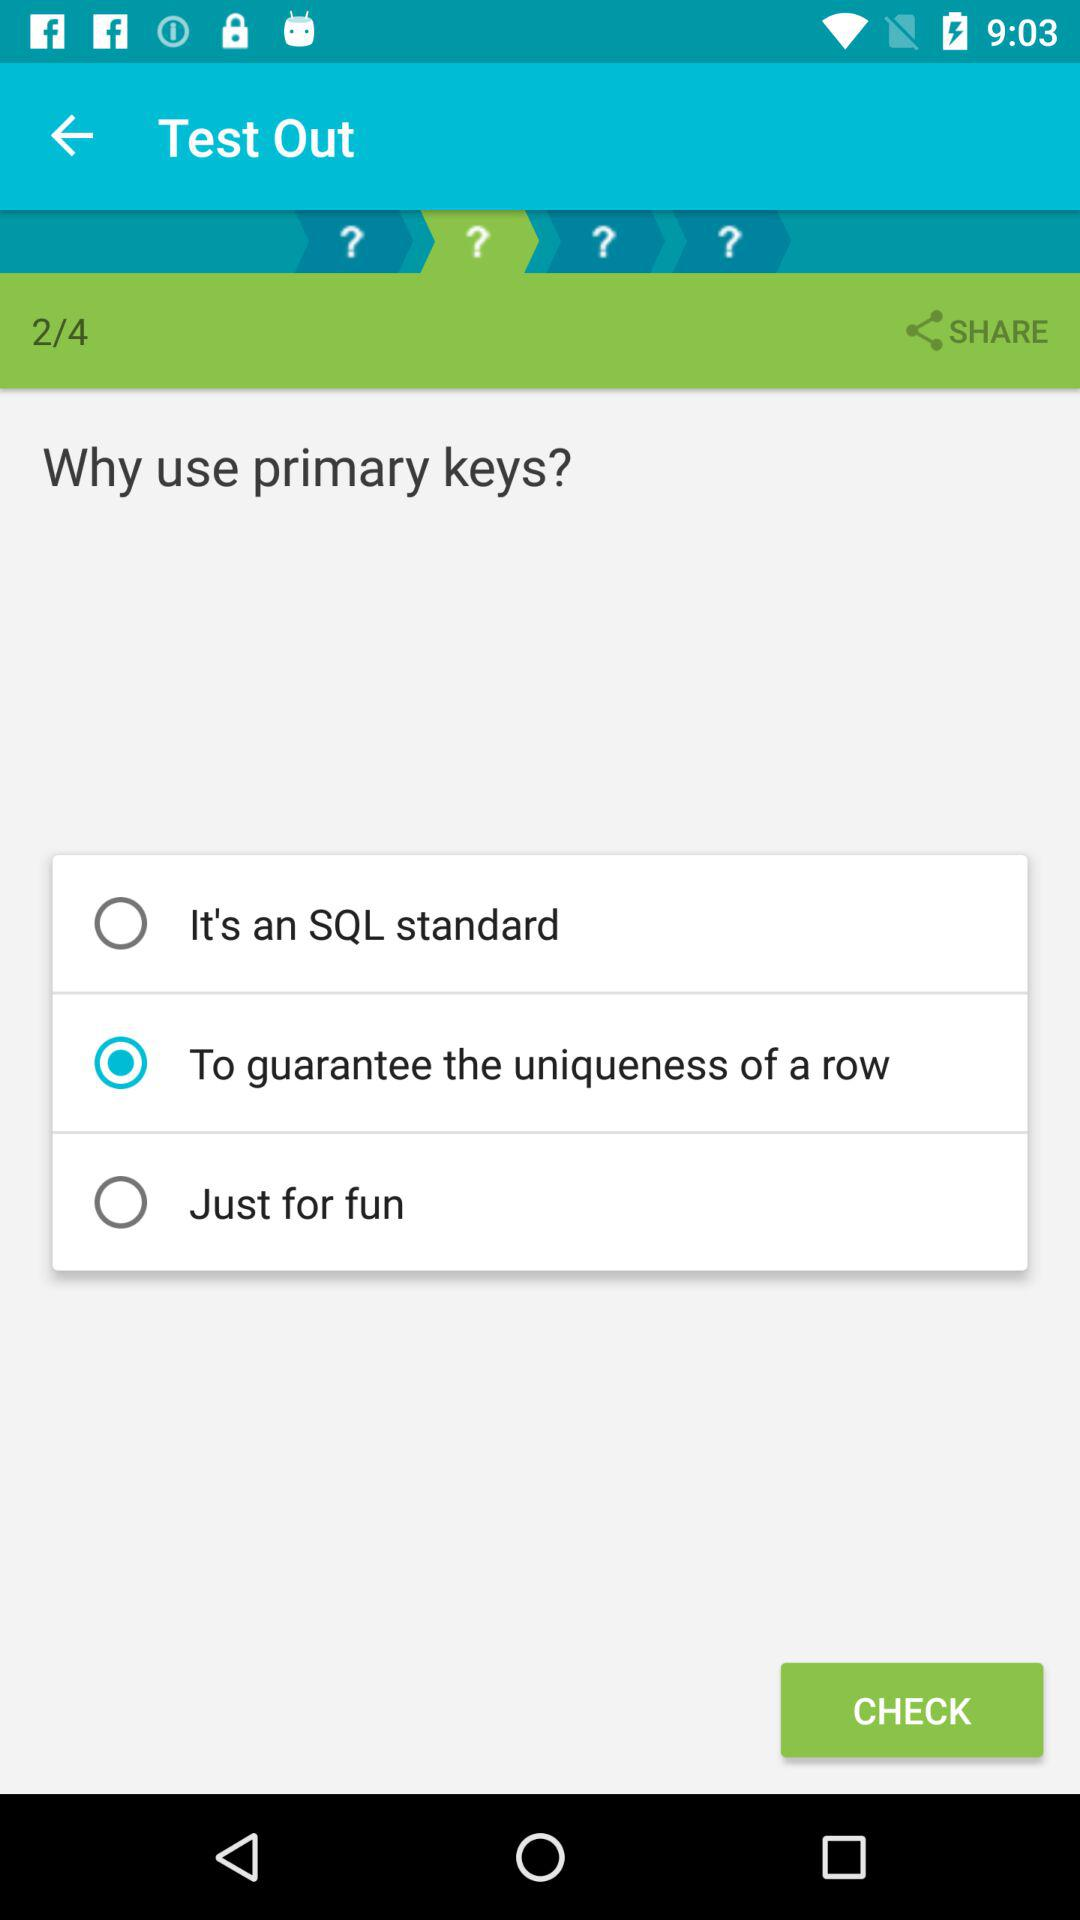How many options are there to answer the question of why use primary keys?
Answer the question using a single word or phrase. 3 